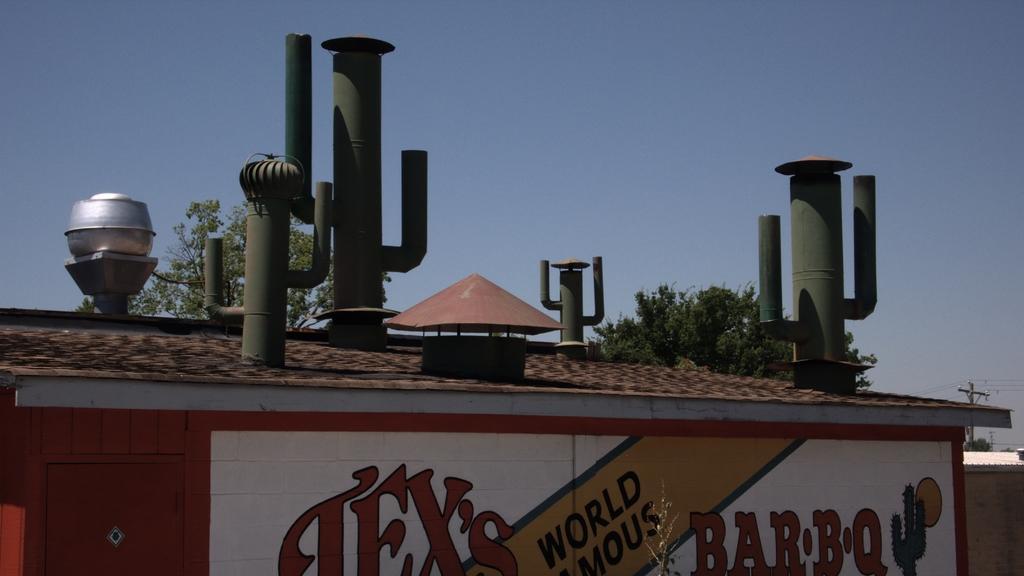Could you give a brief overview of what you see in this image? This picture is clicked outside. In the center we can see a house with a red color roof top and we can see there are some metal objects attached to the house and we can see the text on the wall of the house. In the background there is a ski, pole, cables and trees. 